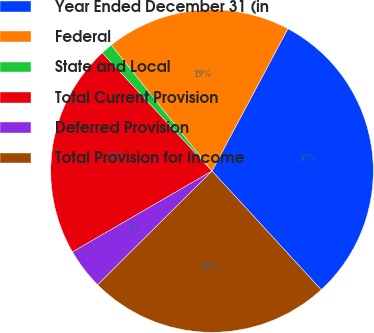Convert chart. <chart><loc_0><loc_0><loc_500><loc_500><pie_chart><fcel>Year Ended December 31 (in<fcel>Federal<fcel>State and Local<fcel>Total Current Provision<fcel>Deferred Provision<fcel>Total Provision for Income<nl><fcel>30.37%<fcel>18.53%<fcel>1.18%<fcel>21.45%<fcel>4.1%<fcel>24.37%<nl></chart> 